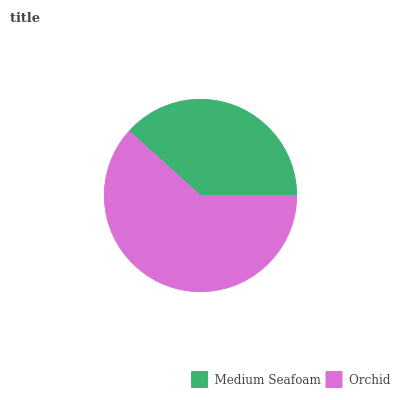Is Medium Seafoam the minimum?
Answer yes or no. Yes. Is Orchid the maximum?
Answer yes or no. Yes. Is Orchid the minimum?
Answer yes or no. No. Is Orchid greater than Medium Seafoam?
Answer yes or no. Yes. Is Medium Seafoam less than Orchid?
Answer yes or no. Yes. Is Medium Seafoam greater than Orchid?
Answer yes or no. No. Is Orchid less than Medium Seafoam?
Answer yes or no. No. Is Orchid the high median?
Answer yes or no. Yes. Is Medium Seafoam the low median?
Answer yes or no. Yes. Is Medium Seafoam the high median?
Answer yes or no. No. Is Orchid the low median?
Answer yes or no. No. 